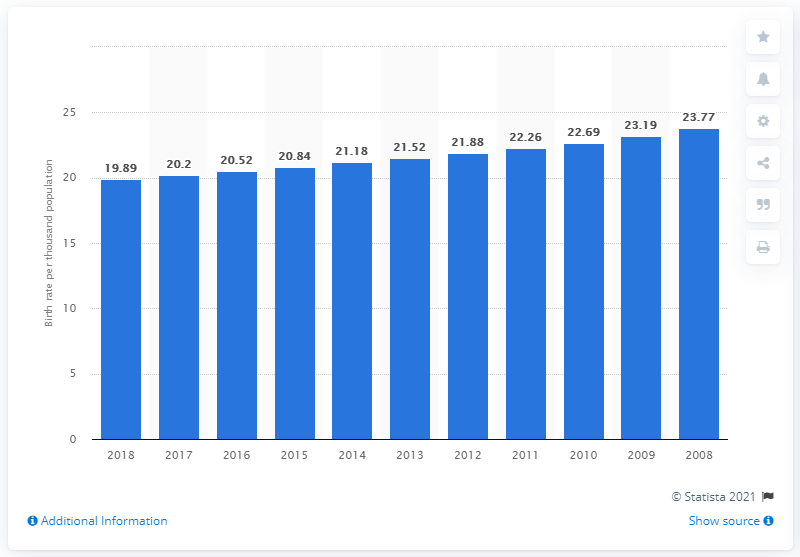Outline some significant characteristics in this image. In 2018, the crude birth rate in Nepal was 19.89. 